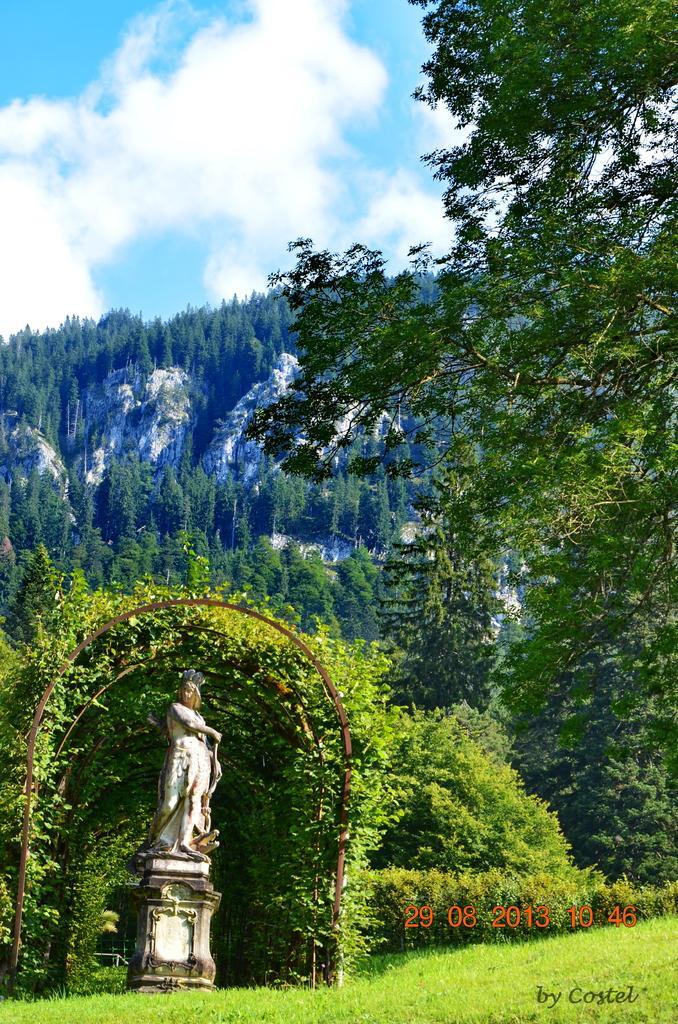Can you describe this image briefly? The picture is taken in a garden or a park. In the foreground of the picture there are plants, trees, grass and a sculpture. In the background the trees and a hill. Sky is bit cloudy and it is sunny. 